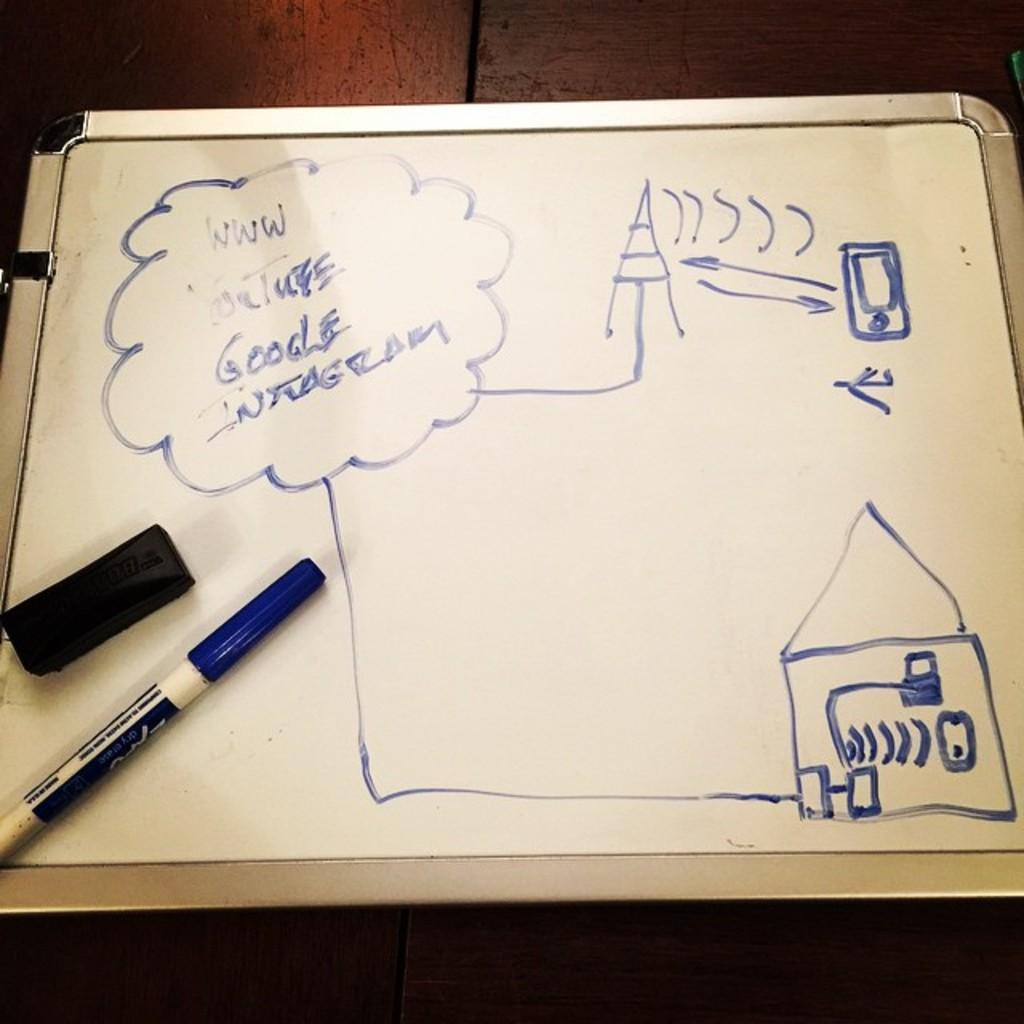<image>
Write a terse but informative summary of the picture. A cloud drawn on a board has the word Google in it. 